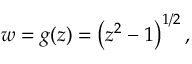<formula> <loc_0><loc_0><loc_500><loc_500>w = g ( z ) = \left ( z ^ { 2 } - 1 \right ) ^ { 1 / 2 } ,</formula> 